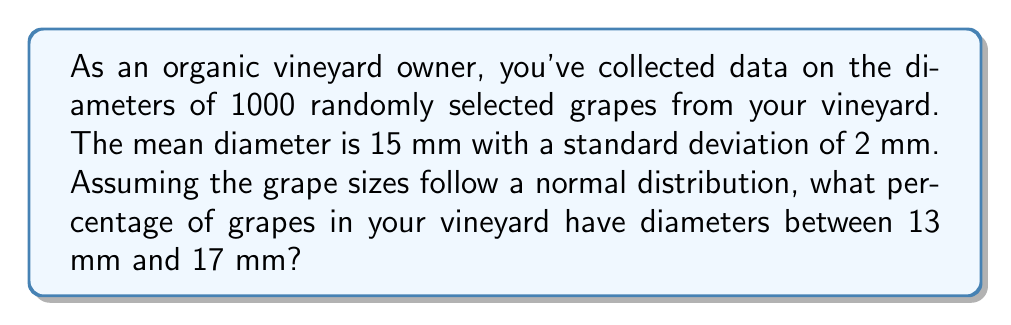Show me your answer to this math problem. To solve this problem, we'll use the properties of the normal distribution and the concept of z-scores.

Step 1: Identify the given information
- Mean (μ) = 15 mm
- Standard deviation (σ) = 2 mm
- We want to find the percentage of grapes between 13 mm and 17 mm

Step 2: Calculate the z-scores for the lower and upper bounds
For the lower bound (13 mm):
$z_1 = \frac{x - \mu}{\sigma} = \frac{13 - 15}{2} = -1$

For the upper bound (17 mm):
$z_2 = \frac{x - \mu}{\sigma} = \frac{17 - 15}{2} = 1$

Step 3: Use the standard normal distribution table or a calculator to find the area between these z-scores
The area between z = -1 and z = 1 in a standard normal distribution is approximately 0.6826 or 68.26%.

Step 4: Interpret the result
This means that approximately 68.26% of the grapes in your vineyard have diameters between 13 mm and 17 mm.

Note: This result is also known as the "68-95-99.7 rule" or the "empirical rule" for normal distributions, where approximately 68% of the data falls within one standard deviation of the mean.
Answer: 68.26% 